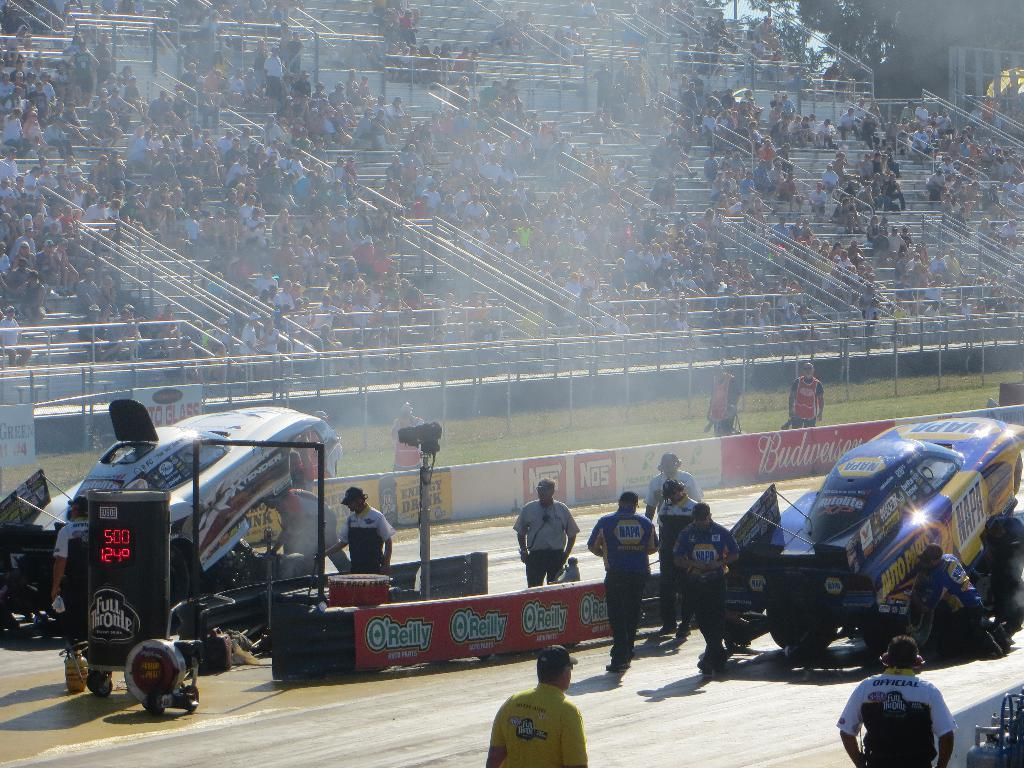What can be seen in the image involving a group of people? There is a group of people in the image. What else is visible on the road in the image? There are vehicles on the road in the image. What can be seen in the background of the image? There is a fence, people, and trees in the background of the image. What type of head can be seen floating in the image? There is no head floating in the image; it only features a group of people, vehicles, a fence, people, and trees in the background. 